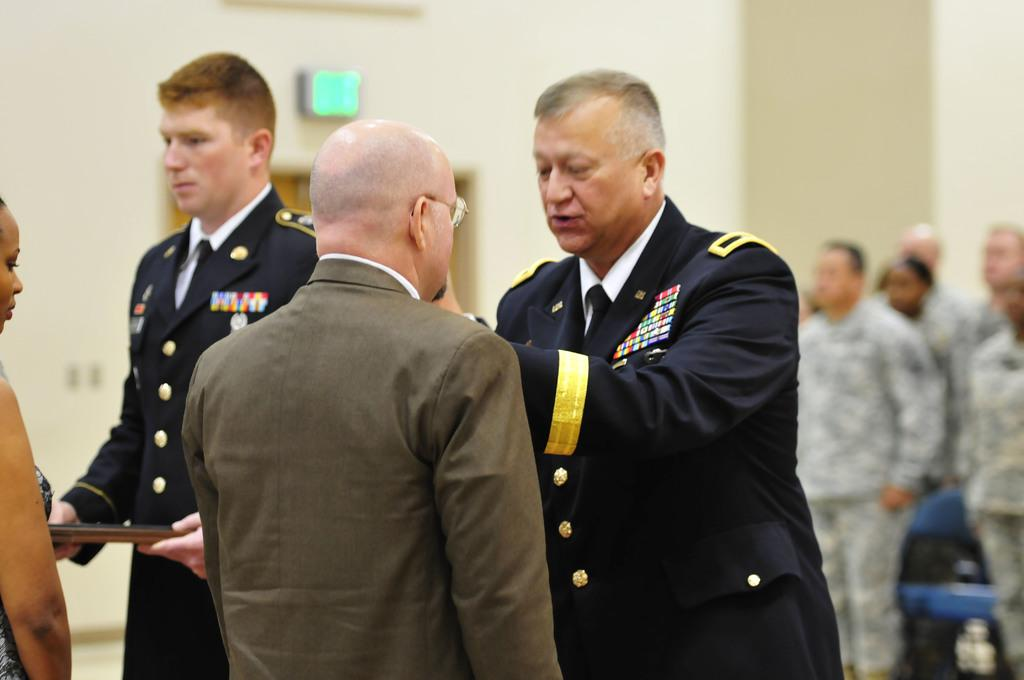Who are the two people in the image? There is a man and a woman in the image. What are the man and woman doing in the image? The man and woman are receiving an honor. Who is presenting the honor to them? Officers are presenting the honor to them. What else can be seen in the background of the image? There are other army personnel standing in the background. What is the current interest rate for the year in the image? There is no information about interest rates or the current year in the image. Can you hear the sound of bells ringing in the image? There is no auditory information in the image, so it is not possible to determine if bells are ringing. 